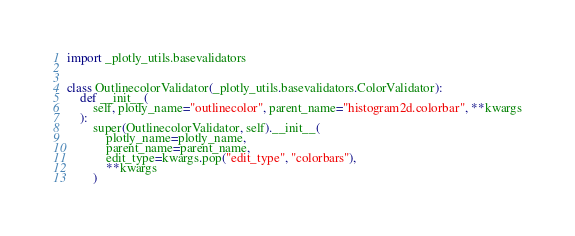<code> <loc_0><loc_0><loc_500><loc_500><_Python_>import _plotly_utils.basevalidators


class OutlinecolorValidator(_plotly_utils.basevalidators.ColorValidator):
    def __init__(
        self, plotly_name="outlinecolor", parent_name="histogram2d.colorbar", **kwargs
    ):
        super(OutlinecolorValidator, self).__init__(
            plotly_name=plotly_name,
            parent_name=parent_name,
            edit_type=kwargs.pop("edit_type", "colorbars"),
            **kwargs
        )
</code> 